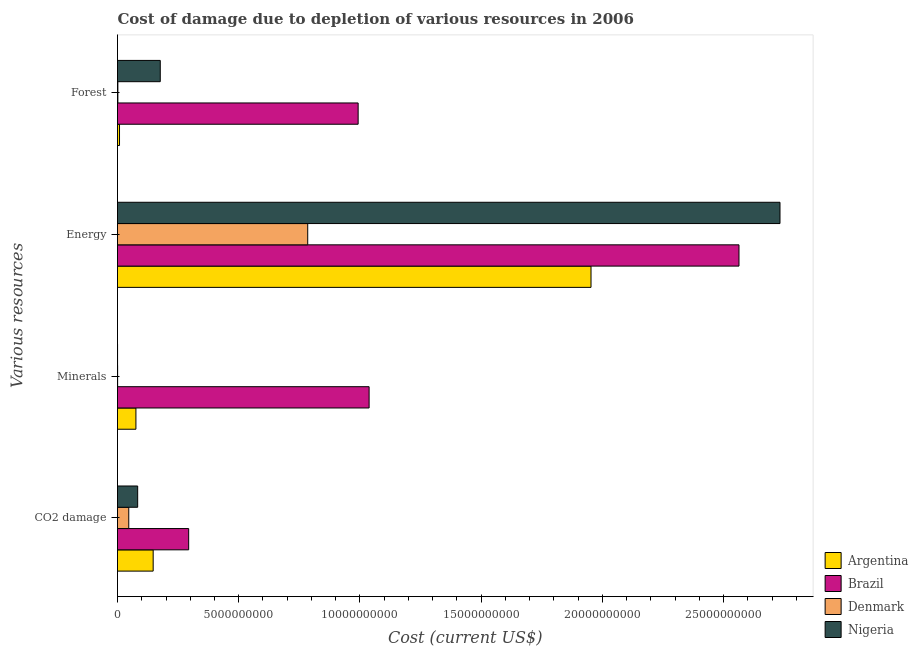What is the label of the 3rd group of bars from the top?
Offer a terse response. Minerals. What is the cost of damage due to depletion of energy in Brazil?
Offer a terse response. 2.56e+1. Across all countries, what is the maximum cost of damage due to depletion of forests?
Your response must be concise. 9.93e+09. Across all countries, what is the minimum cost of damage due to depletion of forests?
Give a very brief answer. 1.52e+07. In which country was the cost of damage due to depletion of minerals maximum?
Your answer should be very brief. Brazil. What is the total cost of damage due to depletion of minerals in the graph?
Provide a succinct answer. 1.11e+1. What is the difference between the cost of damage due to depletion of minerals in Nigeria and that in Denmark?
Ensure brevity in your answer.  -2.60e+06. What is the difference between the cost of damage due to depletion of forests in Denmark and the cost of damage due to depletion of energy in Argentina?
Offer a very short reply. -1.95e+1. What is the average cost of damage due to depletion of minerals per country?
Give a very brief answer. 2.79e+09. What is the difference between the cost of damage due to depletion of minerals and cost of damage due to depletion of forests in Argentina?
Make the answer very short. 6.76e+08. In how many countries, is the cost of damage due to depletion of energy greater than 22000000000 US$?
Your response must be concise. 2. What is the ratio of the cost of damage due to depletion of coal in Brazil to that in Argentina?
Provide a succinct answer. 2. What is the difference between the highest and the second highest cost of damage due to depletion of energy?
Give a very brief answer. 1.69e+09. What is the difference between the highest and the lowest cost of damage due to depletion of forests?
Make the answer very short. 9.91e+09. In how many countries, is the cost of damage due to depletion of minerals greater than the average cost of damage due to depletion of minerals taken over all countries?
Give a very brief answer. 1. Is the sum of the cost of damage due to depletion of energy in Argentina and Nigeria greater than the maximum cost of damage due to depletion of coal across all countries?
Give a very brief answer. Yes. What does the 1st bar from the top in Minerals represents?
Provide a succinct answer. Nigeria. What is the difference between two consecutive major ticks on the X-axis?
Make the answer very short. 5.00e+09. Are the values on the major ticks of X-axis written in scientific E-notation?
Your answer should be compact. No. Does the graph contain grids?
Make the answer very short. No. Where does the legend appear in the graph?
Give a very brief answer. Bottom right. How many legend labels are there?
Your answer should be compact. 4. How are the legend labels stacked?
Keep it short and to the point. Vertical. What is the title of the graph?
Make the answer very short. Cost of damage due to depletion of various resources in 2006 . What is the label or title of the X-axis?
Your answer should be compact. Cost (current US$). What is the label or title of the Y-axis?
Provide a short and direct response. Various resources. What is the Cost (current US$) of Argentina in CO2 damage?
Give a very brief answer. 1.47e+09. What is the Cost (current US$) of Brazil in CO2 damage?
Your response must be concise. 2.94e+09. What is the Cost (current US$) of Denmark in CO2 damage?
Make the answer very short. 4.64e+08. What is the Cost (current US$) in Nigeria in CO2 damage?
Make the answer very short. 8.32e+08. What is the Cost (current US$) in Argentina in Minerals?
Offer a very short reply. 7.60e+08. What is the Cost (current US$) in Brazil in Minerals?
Offer a terse response. 1.04e+1. What is the Cost (current US$) of Denmark in Minerals?
Your response must be concise. 4.75e+06. What is the Cost (current US$) of Nigeria in Minerals?
Make the answer very short. 2.15e+06. What is the Cost (current US$) of Argentina in Energy?
Your response must be concise. 1.95e+1. What is the Cost (current US$) in Brazil in Energy?
Your response must be concise. 2.56e+1. What is the Cost (current US$) in Denmark in Energy?
Offer a very short reply. 7.84e+09. What is the Cost (current US$) in Nigeria in Energy?
Offer a very short reply. 2.73e+1. What is the Cost (current US$) of Argentina in Forest?
Keep it short and to the point. 8.31e+07. What is the Cost (current US$) of Brazil in Forest?
Provide a succinct answer. 9.93e+09. What is the Cost (current US$) in Denmark in Forest?
Provide a succinct answer. 1.52e+07. What is the Cost (current US$) of Nigeria in Forest?
Your answer should be very brief. 1.76e+09. Across all Various resources, what is the maximum Cost (current US$) in Argentina?
Your answer should be very brief. 1.95e+1. Across all Various resources, what is the maximum Cost (current US$) of Brazil?
Your answer should be compact. 2.56e+1. Across all Various resources, what is the maximum Cost (current US$) of Denmark?
Your response must be concise. 7.84e+09. Across all Various resources, what is the maximum Cost (current US$) in Nigeria?
Keep it short and to the point. 2.73e+1. Across all Various resources, what is the minimum Cost (current US$) in Argentina?
Give a very brief answer. 8.31e+07. Across all Various resources, what is the minimum Cost (current US$) of Brazil?
Make the answer very short. 2.94e+09. Across all Various resources, what is the minimum Cost (current US$) in Denmark?
Offer a terse response. 4.75e+06. Across all Various resources, what is the minimum Cost (current US$) of Nigeria?
Your answer should be compact. 2.15e+06. What is the total Cost (current US$) in Argentina in the graph?
Keep it short and to the point. 2.18e+1. What is the total Cost (current US$) of Brazil in the graph?
Your answer should be very brief. 4.89e+1. What is the total Cost (current US$) in Denmark in the graph?
Your response must be concise. 8.33e+09. What is the total Cost (current US$) of Nigeria in the graph?
Make the answer very short. 2.99e+1. What is the difference between the Cost (current US$) in Argentina in CO2 damage and that in Minerals?
Ensure brevity in your answer.  7.11e+08. What is the difference between the Cost (current US$) of Brazil in CO2 damage and that in Minerals?
Offer a very short reply. -7.44e+09. What is the difference between the Cost (current US$) of Denmark in CO2 damage and that in Minerals?
Offer a terse response. 4.59e+08. What is the difference between the Cost (current US$) of Nigeria in CO2 damage and that in Minerals?
Give a very brief answer. 8.30e+08. What is the difference between the Cost (current US$) of Argentina in CO2 damage and that in Energy?
Provide a succinct answer. -1.81e+1. What is the difference between the Cost (current US$) in Brazil in CO2 damage and that in Energy?
Your answer should be very brief. -2.27e+1. What is the difference between the Cost (current US$) in Denmark in CO2 damage and that in Energy?
Your answer should be compact. -7.38e+09. What is the difference between the Cost (current US$) in Nigeria in CO2 damage and that in Energy?
Provide a short and direct response. -2.65e+1. What is the difference between the Cost (current US$) of Argentina in CO2 damage and that in Forest?
Your response must be concise. 1.39e+09. What is the difference between the Cost (current US$) of Brazil in CO2 damage and that in Forest?
Provide a short and direct response. -6.99e+09. What is the difference between the Cost (current US$) in Denmark in CO2 damage and that in Forest?
Make the answer very short. 4.49e+08. What is the difference between the Cost (current US$) of Nigeria in CO2 damage and that in Forest?
Give a very brief answer. -9.32e+08. What is the difference between the Cost (current US$) of Argentina in Minerals and that in Energy?
Provide a short and direct response. -1.88e+1. What is the difference between the Cost (current US$) in Brazil in Minerals and that in Energy?
Ensure brevity in your answer.  -1.53e+1. What is the difference between the Cost (current US$) in Denmark in Minerals and that in Energy?
Your response must be concise. -7.84e+09. What is the difference between the Cost (current US$) in Nigeria in Minerals and that in Energy?
Your answer should be very brief. -2.73e+1. What is the difference between the Cost (current US$) of Argentina in Minerals and that in Forest?
Offer a terse response. 6.76e+08. What is the difference between the Cost (current US$) of Brazil in Minerals and that in Forest?
Provide a short and direct response. 4.52e+08. What is the difference between the Cost (current US$) in Denmark in Minerals and that in Forest?
Make the answer very short. -1.05e+07. What is the difference between the Cost (current US$) in Nigeria in Minerals and that in Forest?
Provide a short and direct response. -1.76e+09. What is the difference between the Cost (current US$) of Argentina in Energy and that in Forest?
Provide a succinct answer. 1.94e+1. What is the difference between the Cost (current US$) in Brazil in Energy and that in Forest?
Ensure brevity in your answer.  1.57e+1. What is the difference between the Cost (current US$) in Denmark in Energy and that in Forest?
Provide a succinct answer. 7.83e+09. What is the difference between the Cost (current US$) of Nigeria in Energy and that in Forest?
Offer a very short reply. 2.56e+1. What is the difference between the Cost (current US$) of Argentina in CO2 damage and the Cost (current US$) of Brazil in Minerals?
Provide a short and direct response. -8.91e+09. What is the difference between the Cost (current US$) of Argentina in CO2 damage and the Cost (current US$) of Denmark in Minerals?
Your answer should be very brief. 1.47e+09. What is the difference between the Cost (current US$) of Argentina in CO2 damage and the Cost (current US$) of Nigeria in Minerals?
Ensure brevity in your answer.  1.47e+09. What is the difference between the Cost (current US$) of Brazil in CO2 damage and the Cost (current US$) of Denmark in Minerals?
Ensure brevity in your answer.  2.93e+09. What is the difference between the Cost (current US$) in Brazil in CO2 damage and the Cost (current US$) in Nigeria in Minerals?
Offer a very short reply. 2.93e+09. What is the difference between the Cost (current US$) of Denmark in CO2 damage and the Cost (current US$) of Nigeria in Minerals?
Provide a short and direct response. 4.62e+08. What is the difference between the Cost (current US$) in Argentina in CO2 damage and the Cost (current US$) in Brazil in Energy?
Offer a very short reply. -2.42e+1. What is the difference between the Cost (current US$) of Argentina in CO2 damage and the Cost (current US$) of Denmark in Energy?
Your answer should be very brief. -6.37e+09. What is the difference between the Cost (current US$) of Argentina in CO2 damage and the Cost (current US$) of Nigeria in Energy?
Your response must be concise. -2.59e+1. What is the difference between the Cost (current US$) in Brazil in CO2 damage and the Cost (current US$) in Denmark in Energy?
Provide a short and direct response. -4.91e+09. What is the difference between the Cost (current US$) of Brazil in CO2 damage and the Cost (current US$) of Nigeria in Energy?
Offer a very short reply. -2.44e+1. What is the difference between the Cost (current US$) in Denmark in CO2 damage and the Cost (current US$) in Nigeria in Energy?
Offer a terse response. -2.69e+1. What is the difference between the Cost (current US$) in Argentina in CO2 damage and the Cost (current US$) in Brazil in Forest?
Make the answer very short. -8.45e+09. What is the difference between the Cost (current US$) of Argentina in CO2 damage and the Cost (current US$) of Denmark in Forest?
Your response must be concise. 1.46e+09. What is the difference between the Cost (current US$) of Argentina in CO2 damage and the Cost (current US$) of Nigeria in Forest?
Provide a short and direct response. -2.93e+08. What is the difference between the Cost (current US$) in Brazil in CO2 damage and the Cost (current US$) in Denmark in Forest?
Offer a terse response. 2.92e+09. What is the difference between the Cost (current US$) of Brazil in CO2 damage and the Cost (current US$) of Nigeria in Forest?
Make the answer very short. 1.17e+09. What is the difference between the Cost (current US$) of Denmark in CO2 damage and the Cost (current US$) of Nigeria in Forest?
Offer a very short reply. -1.30e+09. What is the difference between the Cost (current US$) of Argentina in Minerals and the Cost (current US$) of Brazil in Energy?
Offer a terse response. -2.49e+1. What is the difference between the Cost (current US$) in Argentina in Minerals and the Cost (current US$) in Denmark in Energy?
Provide a succinct answer. -7.09e+09. What is the difference between the Cost (current US$) of Argentina in Minerals and the Cost (current US$) of Nigeria in Energy?
Your response must be concise. -2.66e+1. What is the difference between the Cost (current US$) of Brazil in Minerals and the Cost (current US$) of Denmark in Energy?
Your answer should be compact. 2.53e+09. What is the difference between the Cost (current US$) of Brazil in Minerals and the Cost (current US$) of Nigeria in Energy?
Provide a short and direct response. -1.69e+1. What is the difference between the Cost (current US$) in Denmark in Minerals and the Cost (current US$) in Nigeria in Energy?
Offer a very short reply. -2.73e+1. What is the difference between the Cost (current US$) of Argentina in Minerals and the Cost (current US$) of Brazil in Forest?
Your response must be concise. -9.17e+09. What is the difference between the Cost (current US$) in Argentina in Minerals and the Cost (current US$) in Denmark in Forest?
Ensure brevity in your answer.  7.44e+08. What is the difference between the Cost (current US$) of Argentina in Minerals and the Cost (current US$) of Nigeria in Forest?
Make the answer very short. -1.00e+09. What is the difference between the Cost (current US$) in Brazil in Minerals and the Cost (current US$) in Denmark in Forest?
Offer a very short reply. 1.04e+1. What is the difference between the Cost (current US$) in Brazil in Minerals and the Cost (current US$) in Nigeria in Forest?
Provide a succinct answer. 8.61e+09. What is the difference between the Cost (current US$) in Denmark in Minerals and the Cost (current US$) in Nigeria in Forest?
Make the answer very short. -1.76e+09. What is the difference between the Cost (current US$) in Argentina in Energy and the Cost (current US$) in Brazil in Forest?
Ensure brevity in your answer.  9.60e+09. What is the difference between the Cost (current US$) in Argentina in Energy and the Cost (current US$) in Denmark in Forest?
Offer a very short reply. 1.95e+1. What is the difference between the Cost (current US$) in Argentina in Energy and the Cost (current US$) in Nigeria in Forest?
Offer a very short reply. 1.78e+1. What is the difference between the Cost (current US$) in Brazil in Energy and the Cost (current US$) in Denmark in Forest?
Keep it short and to the point. 2.56e+1. What is the difference between the Cost (current US$) of Brazil in Energy and the Cost (current US$) of Nigeria in Forest?
Offer a terse response. 2.39e+1. What is the difference between the Cost (current US$) in Denmark in Energy and the Cost (current US$) in Nigeria in Forest?
Your answer should be compact. 6.08e+09. What is the average Cost (current US$) in Argentina per Various resources?
Make the answer very short. 5.46e+09. What is the average Cost (current US$) of Brazil per Various resources?
Make the answer very short. 1.22e+1. What is the average Cost (current US$) of Denmark per Various resources?
Keep it short and to the point. 2.08e+09. What is the average Cost (current US$) of Nigeria per Various resources?
Offer a very short reply. 7.48e+09. What is the difference between the Cost (current US$) in Argentina and Cost (current US$) in Brazil in CO2 damage?
Your response must be concise. -1.46e+09. What is the difference between the Cost (current US$) of Argentina and Cost (current US$) of Denmark in CO2 damage?
Provide a short and direct response. 1.01e+09. What is the difference between the Cost (current US$) in Argentina and Cost (current US$) in Nigeria in CO2 damage?
Provide a succinct answer. 6.39e+08. What is the difference between the Cost (current US$) of Brazil and Cost (current US$) of Denmark in CO2 damage?
Keep it short and to the point. 2.47e+09. What is the difference between the Cost (current US$) in Brazil and Cost (current US$) in Nigeria in CO2 damage?
Offer a very short reply. 2.10e+09. What is the difference between the Cost (current US$) in Denmark and Cost (current US$) in Nigeria in CO2 damage?
Provide a short and direct response. -3.67e+08. What is the difference between the Cost (current US$) in Argentina and Cost (current US$) in Brazil in Minerals?
Offer a terse response. -9.62e+09. What is the difference between the Cost (current US$) of Argentina and Cost (current US$) of Denmark in Minerals?
Offer a very short reply. 7.55e+08. What is the difference between the Cost (current US$) in Argentina and Cost (current US$) in Nigeria in Minerals?
Your answer should be very brief. 7.57e+08. What is the difference between the Cost (current US$) in Brazil and Cost (current US$) in Denmark in Minerals?
Make the answer very short. 1.04e+1. What is the difference between the Cost (current US$) of Brazil and Cost (current US$) of Nigeria in Minerals?
Your answer should be compact. 1.04e+1. What is the difference between the Cost (current US$) in Denmark and Cost (current US$) in Nigeria in Minerals?
Give a very brief answer. 2.60e+06. What is the difference between the Cost (current US$) in Argentina and Cost (current US$) in Brazil in Energy?
Offer a very short reply. -6.10e+09. What is the difference between the Cost (current US$) in Argentina and Cost (current US$) in Denmark in Energy?
Your response must be concise. 1.17e+1. What is the difference between the Cost (current US$) of Argentina and Cost (current US$) of Nigeria in Energy?
Provide a short and direct response. -7.79e+09. What is the difference between the Cost (current US$) of Brazil and Cost (current US$) of Denmark in Energy?
Make the answer very short. 1.78e+1. What is the difference between the Cost (current US$) in Brazil and Cost (current US$) in Nigeria in Energy?
Offer a very short reply. -1.69e+09. What is the difference between the Cost (current US$) of Denmark and Cost (current US$) of Nigeria in Energy?
Your answer should be compact. -1.95e+1. What is the difference between the Cost (current US$) of Argentina and Cost (current US$) of Brazil in Forest?
Offer a terse response. -9.84e+09. What is the difference between the Cost (current US$) in Argentina and Cost (current US$) in Denmark in Forest?
Provide a short and direct response. 6.79e+07. What is the difference between the Cost (current US$) in Argentina and Cost (current US$) in Nigeria in Forest?
Offer a terse response. -1.68e+09. What is the difference between the Cost (current US$) in Brazil and Cost (current US$) in Denmark in Forest?
Your response must be concise. 9.91e+09. What is the difference between the Cost (current US$) in Brazil and Cost (current US$) in Nigeria in Forest?
Provide a short and direct response. 8.16e+09. What is the difference between the Cost (current US$) of Denmark and Cost (current US$) of Nigeria in Forest?
Give a very brief answer. -1.75e+09. What is the ratio of the Cost (current US$) of Argentina in CO2 damage to that in Minerals?
Ensure brevity in your answer.  1.94. What is the ratio of the Cost (current US$) of Brazil in CO2 damage to that in Minerals?
Your response must be concise. 0.28. What is the ratio of the Cost (current US$) in Denmark in CO2 damage to that in Minerals?
Keep it short and to the point. 97.72. What is the ratio of the Cost (current US$) of Nigeria in CO2 damage to that in Minerals?
Make the answer very short. 387.35. What is the ratio of the Cost (current US$) in Argentina in CO2 damage to that in Energy?
Offer a terse response. 0.08. What is the ratio of the Cost (current US$) of Brazil in CO2 damage to that in Energy?
Provide a succinct answer. 0.11. What is the ratio of the Cost (current US$) of Denmark in CO2 damage to that in Energy?
Offer a very short reply. 0.06. What is the ratio of the Cost (current US$) in Nigeria in CO2 damage to that in Energy?
Your answer should be compact. 0.03. What is the ratio of the Cost (current US$) in Argentina in CO2 damage to that in Forest?
Offer a terse response. 17.71. What is the ratio of the Cost (current US$) in Brazil in CO2 damage to that in Forest?
Your answer should be very brief. 0.3. What is the ratio of the Cost (current US$) of Denmark in CO2 damage to that in Forest?
Make the answer very short. 30.52. What is the ratio of the Cost (current US$) in Nigeria in CO2 damage to that in Forest?
Give a very brief answer. 0.47. What is the ratio of the Cost (current US$) in Argentina in Minerals to that in Energy?
Your answer should be very brief. 0.04. What is the ratio of the Cost (current US$) in Brazil in Minerals to that in Energy?
Provide a succinct answer. 0.4. What is the ratio of the Cost (current US$) of Denmark in Minerals to that in Energy?
Provide a short and direct response. 0. What is the ratio of the Cost (current US$) in Argentina in Minerals to that in Forest?
Offer a very short reply. 9.14. What is the ratio of the Cost (current US$) in Brazil in Minerals to that in Forest?
Offer a terse response. 1.05. What is the ratio of the Cost (current US$) in Denmark in Minerals to that in Forest?
Provide a succinct answer. 0.31. What is the ratio of the Cost (current US$) of Nigeria in Minerals to that in Forest?
Make the answer very short. 0. What is the ratio of the Cost (current US$) in Argentina in Energy to that in Forest?
Your answer should be compact. 235.09. What is the ratio of the Cost (current US$) of Brazil in Energy to that in Forest?
Ensure brevity in your answer.  2.58. What is the ratio of the Cost (current US$) in Denmark in Energy to that in Forest?
Offer a terse response. 515.82. What is the ratio of the Cost (current US$) of Nigeria in Energy to that in Forest?
Your answer should be compact. 15.49. What is the difference between the highest and the second highest Cost (current US$) in Argentina?
Offer a terse response. 1.81e+1. What is the difference between the highest and the second highest Cost (current US$) of Brazil?
Give a very brief answer. 1.53e+1. What is the difference between the highest and the second highest Cost (current US$) in Denmark?
Make the answer very short. 7.38e+09. What is the difference between the highest and the second highest Cost (current US$) in Nigeria?
Your response must be concise. 2.56e+1. What is the difference between the highest and the lowest Cost (current US$) in Argentina?
Make the answer very short. 1.94e+1. What is the difference between the highest and the lowest Cost (current US$) in Brazil?
Give a very brief answer. 2.27e+1. What is the difference between the highest and the lowest Cost (current US$) in Denmark?
Your answer should be very brief. 7.84e+09. What is the difference between the highest and the lowest Cost (current US$) of Nigeria?
Offer a very short reply. 2.73e+1. 